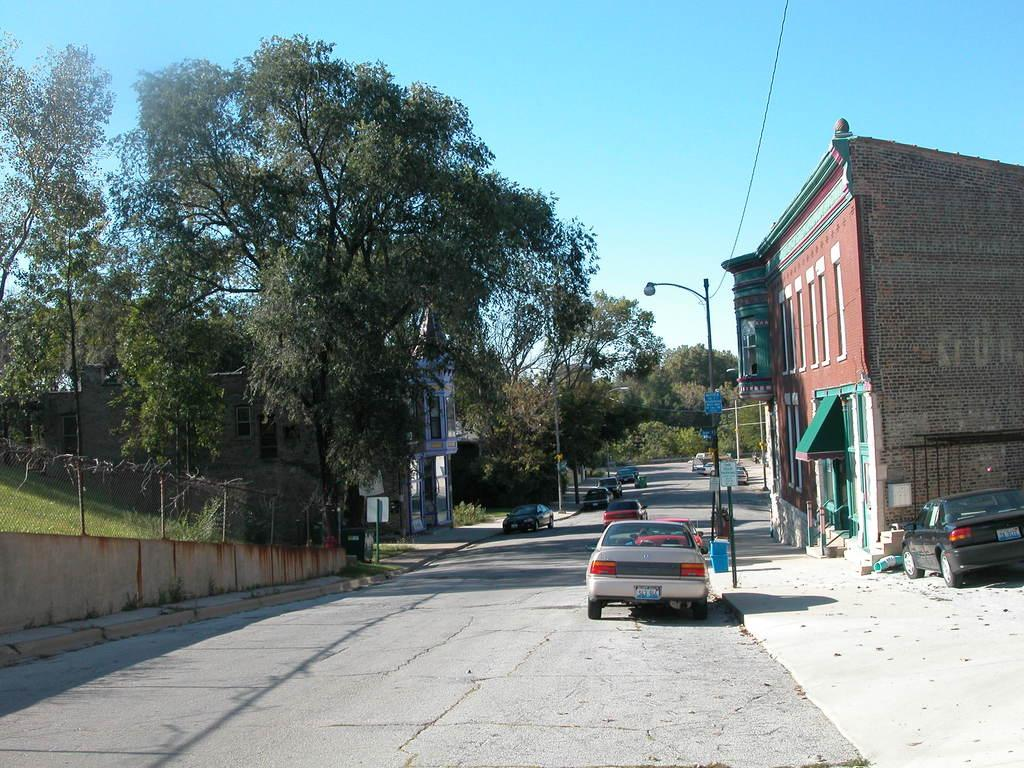Where was the image taken? The image was taken on a road. What can be seen on the road in the image? There are cars parked on the road in the image. What is visible to the left of the image? There are trees to the left of the image. What is visible to the right of the image? There is a building to the right of the image. What type of shelf can be seen in the image? There is no shelf present in the image. What kind of lace is used to decorate the trees in the image? There is no lace used to decorate the trees in the image; they are natural trees. 